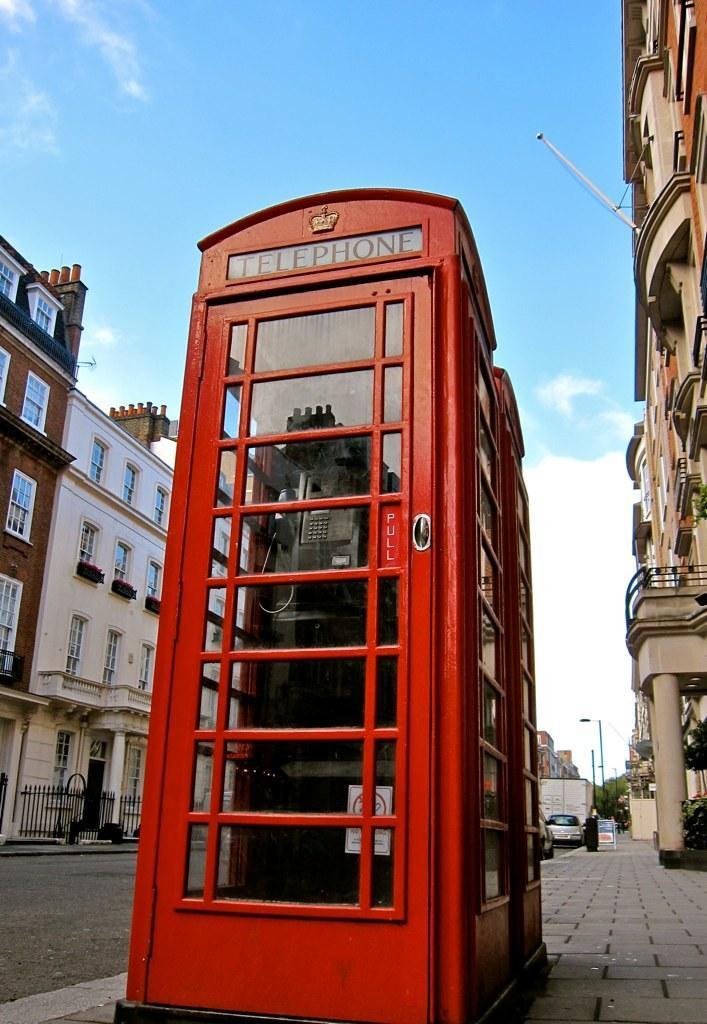Describe this image in one or two sentences. In the middle of the picture, we see a telephone booth. It is in red color. This picture is clicked outside the city. On either side of the picture, we see the buildings. On the left side, we see the railing. On the right side, we see the poles and a board in white color. Beside that, we see a garbage bin and beside that, we see a car. There are buildings and trees in the background. At the top, we see the sky and the clouds. At the bottom, we see the pavement. 